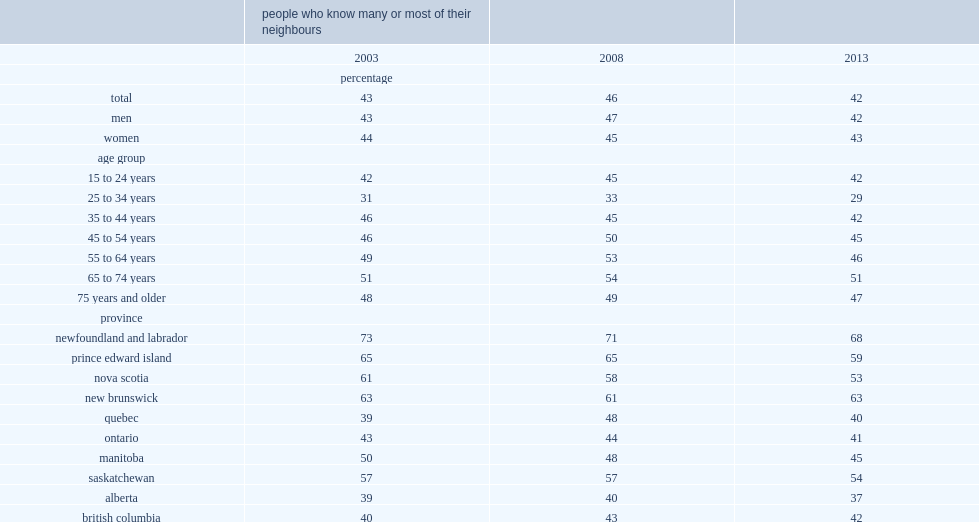What is the proportion of canadians reported knowing many or most of their neighbours in 2013? 42.0. 